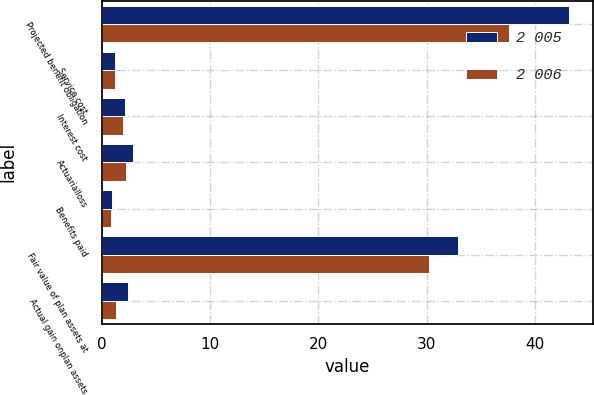Convert chart to OTSL. <chart><loc_0><loc_0><loc_500><loc_500><stacked_bar_chart><ecel><fcel>Projected benefit obligation<fcel>Service cost<fcel>Interest cost<fcel>Actuarialloss<fcel>Benefits paid<fcel>Fair value of plan assets at<fcel>Actual gain onplan assets<nl><fcel>2 005<fcel>43.2<fcel>1.2<fcel>2.1<fcel>2.9<fcel>0.9<fcel>32.9<fcel>2.4<nl><fcel>2 006<fcel>37.6<fcel>1.2<fcel>1.9<fcel>2.2<fcel>0.8<fcel>30.2<fcel>1.3<nl></chart> 